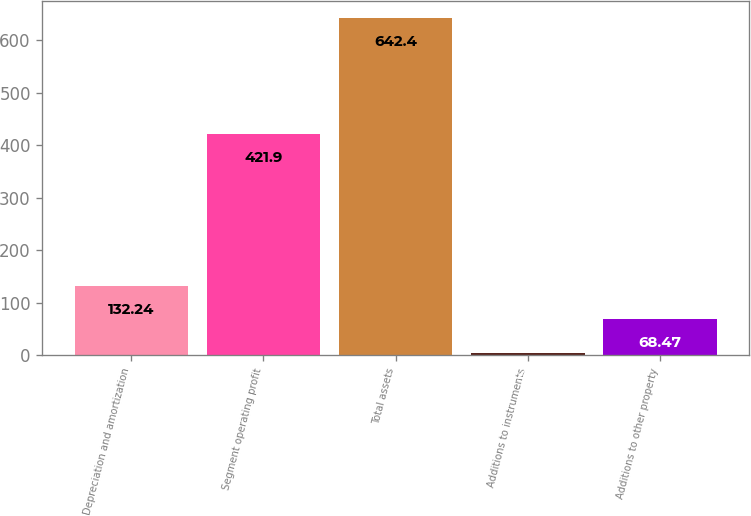<chart> <loc_0><loc_0><loc_500><loc_500><bar_chart><fcel>Depreciation and amortization<fcel>Segment operating profit<fcel>Total assets<fcel>Additions to instruments<fcel>Additions to other property<nl><fcel>132.24<fcel>421.9<fcel>642.4<fcel>4.7<fcel>68.47<nl></chart> 